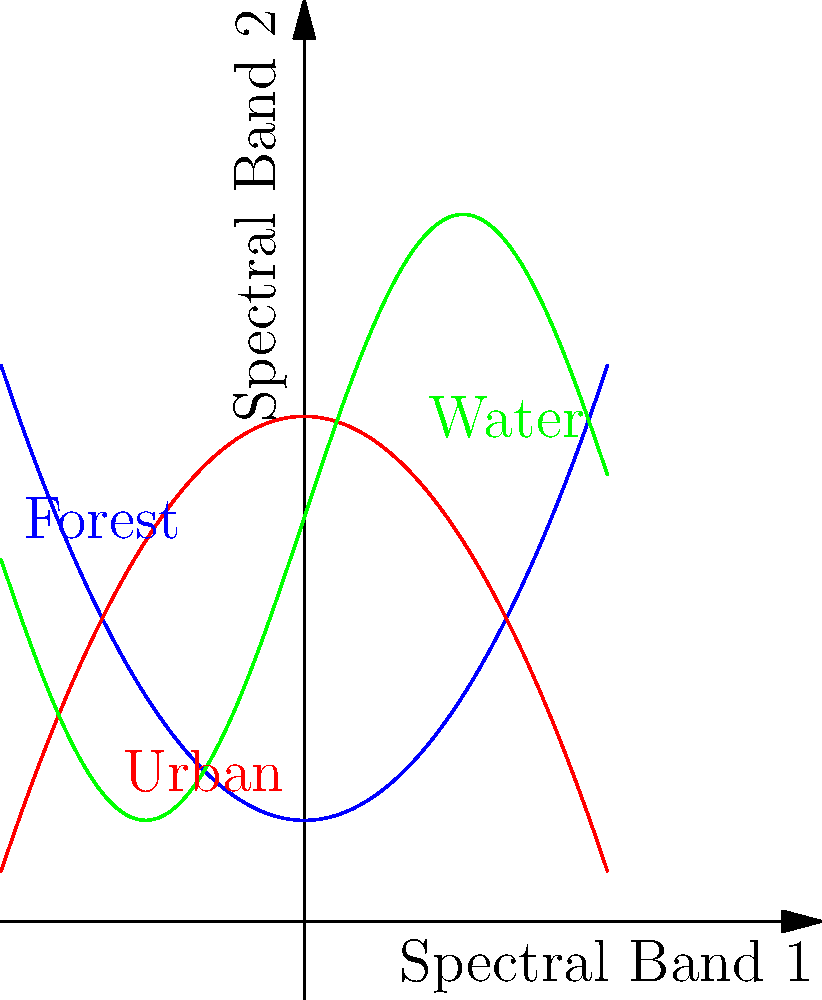In the realm of satellite imagery classification, you stumble upon a peculiar graph showcasing the spectral signatures of different landscapes. As you ponder over this visual anecdote, which machine learning algorithm would be most suitable for classifying these landscapes based on their spectral characteristics? To answer this question, let's analyze the graph and consider the nature of the classification problem:

1. The graph shows three distinct curves representing different landscapes: Forest (blue), Urban (red), and Water (green).

2. These curves are non-linear and have complex shapes, indicating that the relationship between the two spectral bands is not straightforward.

3. The curves intersect at various points, suggesting that simple linear separation might not be effective.

4. We need an algorithm that can handle non-linear decision boundaries and complex relationships between features.

5. Support Vector Machines (SVM) with a non-linear kernel, such as the Radial Basis Function (RBF), would be well-suited for this task because:
   a. It can create non-linear decision boundaries.
   b. It works well with high-dimensional data (multiple spectral bands).
   c. It's effective in cases where the number of dimensions is greater than the number of samples.
   d. It's less prone to overfitting compared to some other non-linear classifiers.

6. While other algorithms like Random Forests or Neural Networks could also be considered, SVM with RBF kernel stands out for its ability to handle complex, non-linear relationships in relatively small datasets, which is often the case in satellite imagery classification.
Answer: Support Vector Machine (SVM) with RBF kernel 